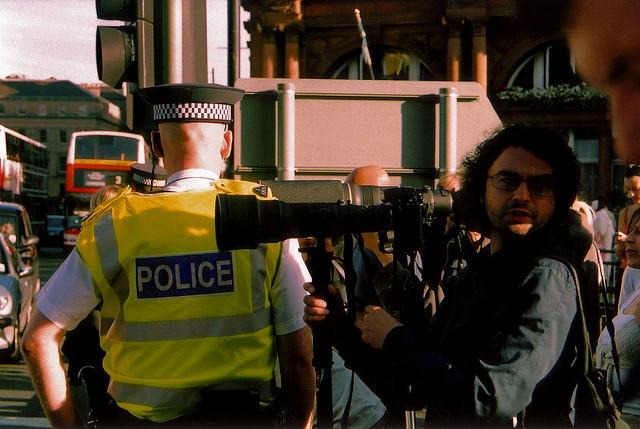What is the occupation of the man wearing a black coat? Please explain your reasoning. news reporter. He has a camera. 